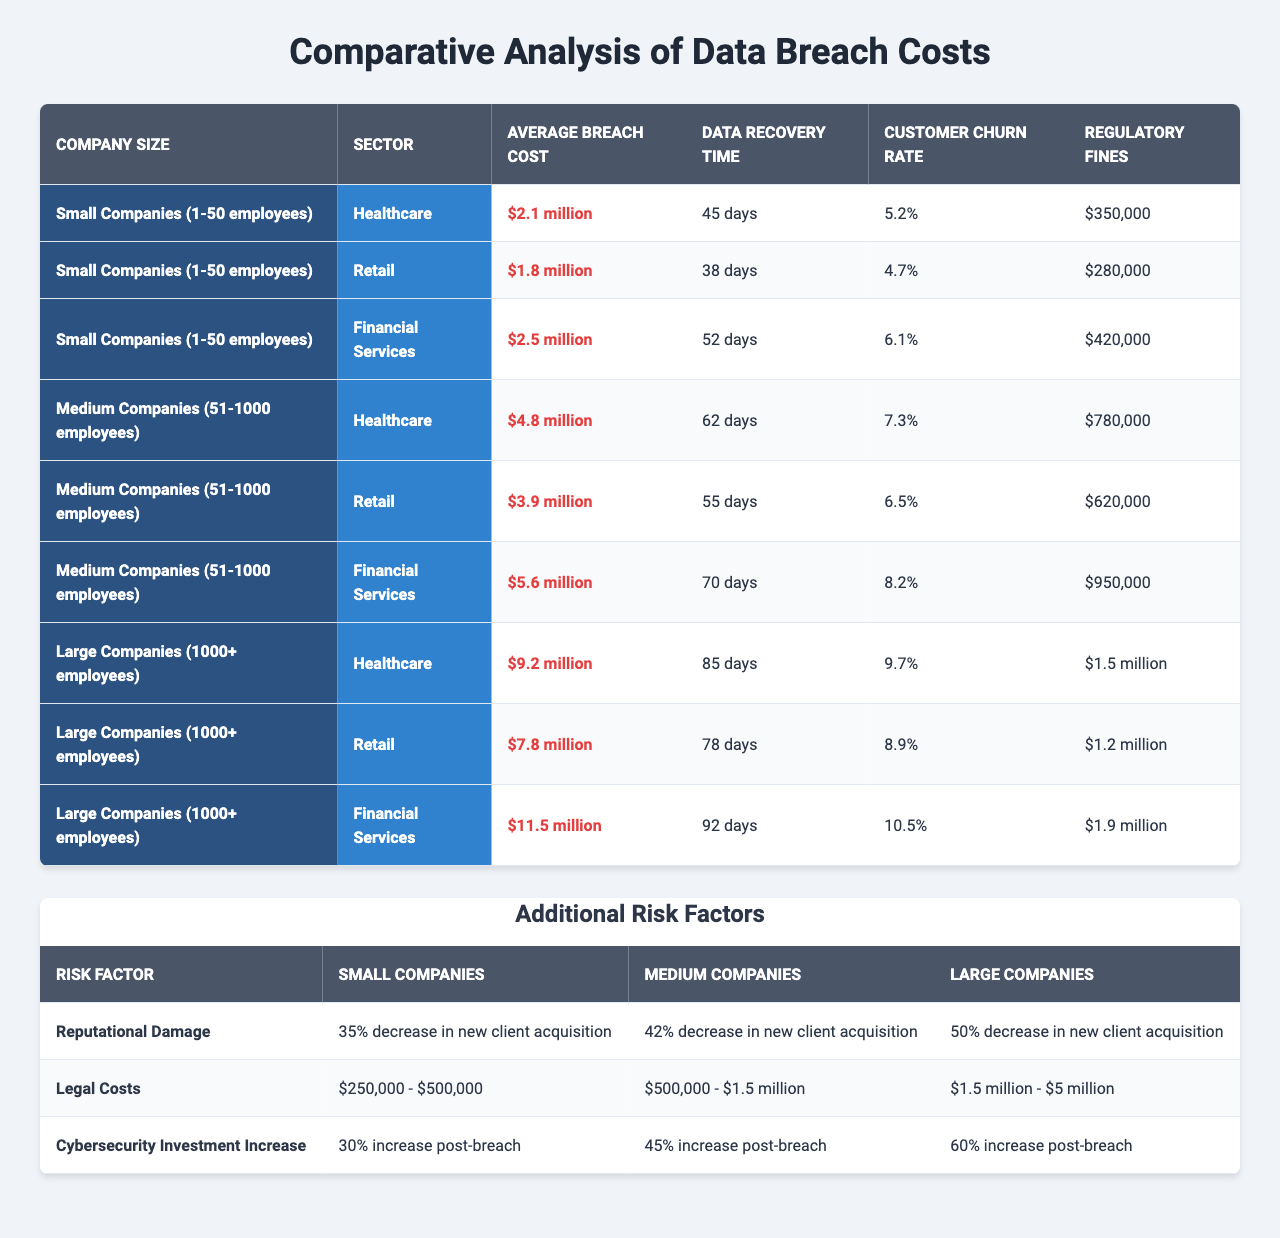What is the average breach cost for small companies in the financial services sector? Referring to the table, the average breach cost listed for small companies in the financial services sector is $2.5 million.
Answer: $2.5 million What is the data recovery time for medium companies in the retail sector? According to the table, the data recovery time for medium companies in the retail sector is 55 days.
Answer: 55 days Which company size sector has the highest average breach cost? By evaluating the values in the "Average Breach Cost" column, large companies in the financial services sector have the highest average breach cost at $11.5 million.
Answer: $11.5 million What is the customer churn rate for large companies in healthcare? Looking at the table, large companies in the healthcare sector have a customer churn rate of 9.7%.
Answer: 9.7% What is the difference in average breach cost between small and medium companies in retail? The average breach cost for small retail companies is $1.8 million, while it is $3.9 million for medium retail companies. The difference is calculated as $3.9 million - $1.8 million = $2.1 million.
Answer: $2.1 million Do all company sizes experience an increase in cybersecurity investment post-breach? Yes, based on the data, all company sizes indicate a percentage increase in cybersecurity investment after a breach, confirming that this fact is true.
Answer: Yes What is the average recovery time for the healthcare sector across all company sizes? The average recovery time can be calculated by averaging the respective times: (45 + 62 + 85) days for small, medium, and large companies, which gives a total of 192 days divided by 3, resulting in an average recovery time of 64 days.
Answer: 64 days Which sector has the largest regulatory fines for large companies? By analyzing the regulatory fines for large companies, the financial services sector has the highest fines at $1.9 million.
Answer: $1.9 million If a medium company experiences a breach, what would be the estimated range of legal costs they might incur? The table indicates that legal costs for medium companies range from $500,000 to $1.5 million.
Answer: $500,000 - $1.5 million How much more do large companies invest in cybersecurity post-breach compared to small companies? The increase in cybersecurity investment for large companies is 60%, and for small companies, it's 30%. The difference is 60% - 30% = 30%.
Answer: 30% 